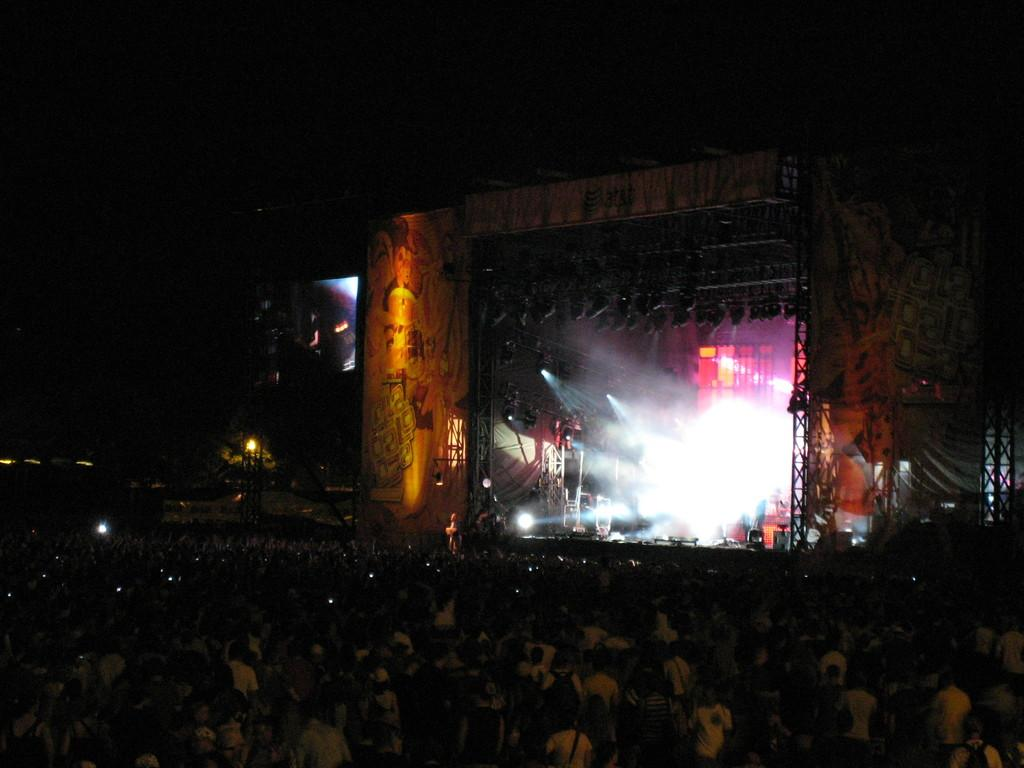What is the main feature of the image? There is a stage in the image. What can be seen illuminating the stage? Stage lights are present in the image. What is located behind the stage? There is a screen in the image. Who or what can be seen in the image? There are people visible in the image. How would you describe the lighting conditions at the top of the image? The top part of the image is dark. What type of jelly is being served to the audience in the image? There is no jelly present in the image; it is a stage with people and stage lights. Can you see a ship in the image? There is no ship visible in the image; it features a stage, stage lights, a screen, and people. 